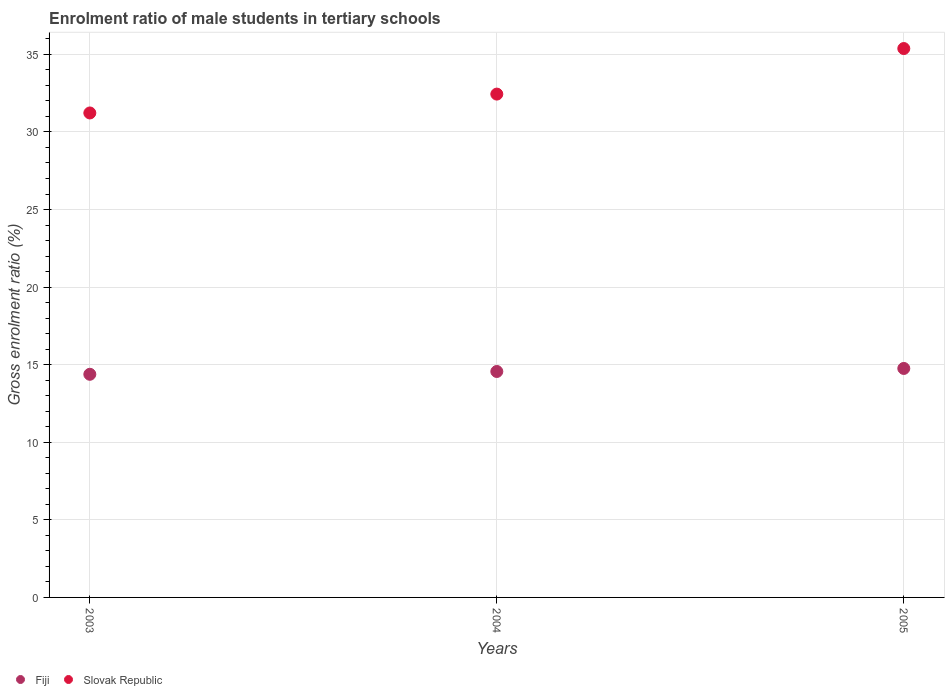How many different coloured dotlines are there?
Offer a very short reply. 2. What is the enrolment ratio of male students in tertiary schools in Slovak Republic in 2004?
Give a very brief answer. 32.44. Across all years, what is the maximum enrolment ratio of male students in tertiary schools in Slovak Republic?
Your answer should be very brief. 35.38. Across all years, what is the minimum enrolment ratio of male students in tertiary schools in Slovak Republic?
Provide a short and direct response. 31.22. In which year was the enrolment ratio of male students in tertiary schools in Fiji maximum?
Make the answer very short. 2005. What is the total enrolment ratio of male students in tertiary schools in Slovak Republic in the graph?
Provide a short and direct response. 99.04. What is the difference between the enrolment ratio of male students in tertiary schools in Slovak Republic in 2004 and that in 2005?
Offer a terse response. -2.94. What is the difference between the enrolment ratio of male students in tertiary schools in Slovak Republic in 2003 and the enrolment ratio of male students in tertiary schools in Fiji in 2005?
Make the answer very short. 16.47. What is the average enrolment ratio of male students in tertiary schools in Slovak Republic per year?
Offer a very short reply. 33.01. In the year 2005, what is the difference between the enrolment ratio of male students in tertiary schools in Fiji and enrolment ratio of male students in tertiary schools in Slovak Republic?
Offer a very short reply. -20.62. What is the ratio of the enrolment ratio of male students in tertiary schools in Fiji in 2004 to that in 2005?
Your answer should be compact. 0.99. Is the difference between the enrolment ratio of male students in tertiary schools in Fiji in 2003 and 2005 greater than the difference between the enrolment ratio of male students in tertiary schools in Slovak Republic in 2003 and 2005?
Give a very brief answer. Yes. What is the difference between the highest and the second highest enrolment ratio of male students in tertiary schools in Fiji?
Make the answer very short. 0.2. What is the difference between the highest and the lowest enrolment ratio of male students in tertiary schools in Slovak Republic?
Your response must be concise. 4.15. In how many years, is the enrolment ratio of male students in tertiary schools in Slovak Republic greater than the average enrolment ratio of male students in tertiary schools in Slovak Republic taken over all years?
Your answer should be very brief. 1. Is the sum of the enrolment ratio of male students in tertiary schools in Slovak Republic in 2004 and 2005 greater than the maximum enrolment ratio of male students in tertiary schools in Fiji across all years?
Your answer should be very brief. Yes. How many years are there in the graph?
Give a very brief answer. 3. What is the difference between two consecutive major ticks on the Y-axis?
Make the answer very short. 5. Does the graph contain grids?
Ensure brevity in your answer.  Yes. How many legend labels are there?
Provide a succinct answer. 2. How are the legend labels stacked?
Your response must be concise. Horizontal. What is the title of the graph?
Your answer should be very brief. Enrolment ratio of male students in tertiary schools. What is the label or title of the Y-axis?
Make the answer very short. Gross enrolment ratio (%). What is the Gross enrolment ratio (%) of Fiji in 2003?
Ensure brevity in your answer.  14.38. What is the Gross enrolment ratio (%) in Slovak Republic in 2003?
Your answer should be compact. 31.22. What is the Gross enrolment ratio (%) in Fiji in 2004?
Ensure brevity in your answer.  14.56. What is the Gross enrolment ratio (%) of Slovak Republic in 2004?
Give a very brief answer. 32.44. What is the Gross enrolment ratio (%) of Fiji in 2005?
Your response must be concise. 14.76. What is the Gross enrolment ratio (%) in Slovak Republic in 2005?
Provide a succinct answer. 35.38. Across all years, what is the maximum Gross enrolment ratio (%) in Fiji?
Make the answer very short. 14.76. Across all years, what is the maximum Gross enrolment ratio (%) of Slovak Republic?
Ensure brevity in your answer.  35.38. Across all years, what is the minimum Gross enrolment ratio (%) of Fiji?
Provide a short and direct response. 14.38. Across all years, what is the minimum Gross enrolment ratio (%) in Slovak Republic?
Give a very brief answer. 31.22. What is the total Gross enrolment ratio (%) of Fiji in the graph?
Keep it short and to the point. 43.7. What is the total Gross enrolment ratio (%) in Slovak Republic in the graph?
Ensure brevity in your answer.  99.04. What is the difference between the Gross enrolment ratio (%) of Fiji in 2003 and that in 2004?
Make the answer very short. -0.18. What is the difference between the Gross enrolment ratio (%) of Slovak Republic in 2003 and that in 2004?
Provide a short and direct response. -1.22. What is the difference between the Gross enrolment ratio (%) of Fiji in 2003 and that in 2005?
Give a very brief answer. -0.38. What is the difference between the Gross enrolment ratio (%) of Slovak Republic in 2003 and that in 2005?
Ensure brevity in your answer.  -4.15. What is the difference between the Gross enrolment ratio (%) in Fiji in 2004 and that in 2005?
Provide a succinct answer. -0.2. What is the difference between the Gross enrolment ratio (%) of Slovak Republic in 2004 and that in 2005?
Your answer should be compact. -2.94. What is the difference between the Gross enrolment ratio (%) in Fiji in 2003 and the Gross enrolment ratio (%) in Slovak Republic in 2004?
Offer a very short reply. -18.06. What is the difference between the Gross enrolment ratio (%) in Fiji in 2003 and the Gross enrolment ratio (%) in Slovak Republic in 2005?
Your answer should be compact. -20.99. What is the difference between the Gross enrolment ratio (%) in Fiji in 2004 and the Gross enrolment ratio (%) in Slovak Republic in 2005?
Provide a succinct answer. -20.81. What is the average Gross enrolment ratio (%) in Fiji per year?
Give a very brief answer. 14.57. What is the average Gross enrolment ratio (%) in Slovak Republic per year?
Offer a very short reply. 33.01. In the year 2003, what is the difference between the Gross enrolment ratio (%) in Fiji and Gross enrolment ratio (%) in Slovak Republic?
Your answer should be very brief. -16.84. In the year 2004, what is the difference between the Gross enrolment ratio (%) of Fiji and Gross enrolment ratio (%) of Slovak Republic?
Provide a short and direct response. -17.88. In the year 2005, what is the difference between the Gross enrolment ratio (%) of Fiji and Gross enrolment ratio (%) of Slovak Republic?
Offer a terse response. -20.62. What is the ratio of the Gross enrolment ratio (%) in Fiji in 2003 to that in 2004?
Give a very brief answer. 0.99. What is the ratio of the Gross enrolment ratio (%) of Slovak Republic in 2003 to that in 2004?
Your answer should be very brief. 0.96. What is the ratio of the Gross enrolment ratio (%) in Fiji in 2003 to that in 2005?
Offer a very short reply. 0.97. What is the ratio of the Gross enrolment ratio (%) in Slovak Republic in 2003 to that in 2005?
Keep it short and to the point. 0.88. What is the ratio of the Gross enrolment ratio (%) in Fiji in 2004 to that in 2005?
Your answer should be compact. 0.99. What is the ratio of the Gross enrolment ratio (%) of Slovak Republic in 2004 to that in 2005?
Offer a terse response. 0.92. What is the difference between the highest and the second highest Gross enrolment ratio (%) in Fiji?
Your response must be concise. 0.2. What is the difference between the highest and the second highest Gross enrolment ratio (%) of Slovak Republic?
Keep it short and to the point. 2.94. What is the difference between the highest and the lowest Gross enrolment ratio (%) in Fiji?
Give a very brief answer. 0.38. What is the difference between the highest and the lowest Gross enrolment ratio (%) in Slovak Republic?
Provide a short and direct response. 4.15. 